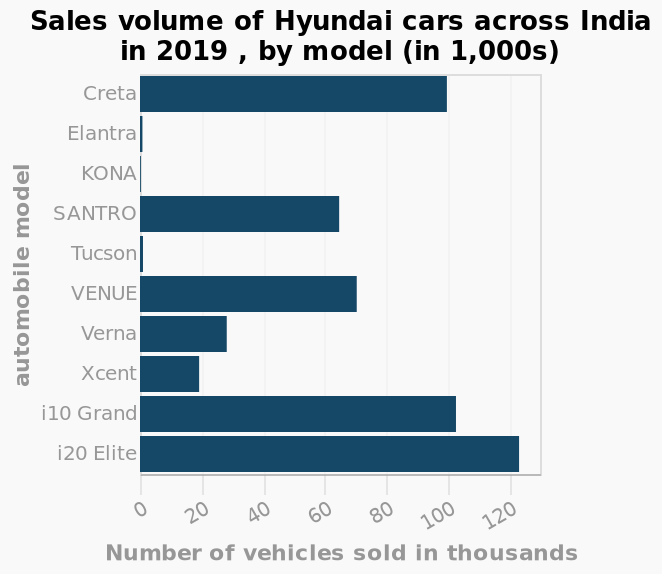<image>
What is the highest selling model of Hyundai cars in India in 2019?  The highest selling model of Hyundai cars in India in 2019 is i20 Elite. Which model had the highest number of sales in India in 2019? The i20 Elite had the highest number of sales in India in 2019 with over 120,000 sales. What was the sales figure for the KONA in 2019? The KONA had less than 10,000 sales in India in 2019. Which specific models of Hyundai cars were considered for the sales volume in India in 2019?  The specific models of Hyundai cars considered for the sales volume in India in 2019 are Creta and i20 Elite. Did the i20 Elite have the lowest number of sales in India in 2019 with under 1,000 sales? No.The i20 Elite had the highest number of sales in India in 2019 with over 120,000 sales. 